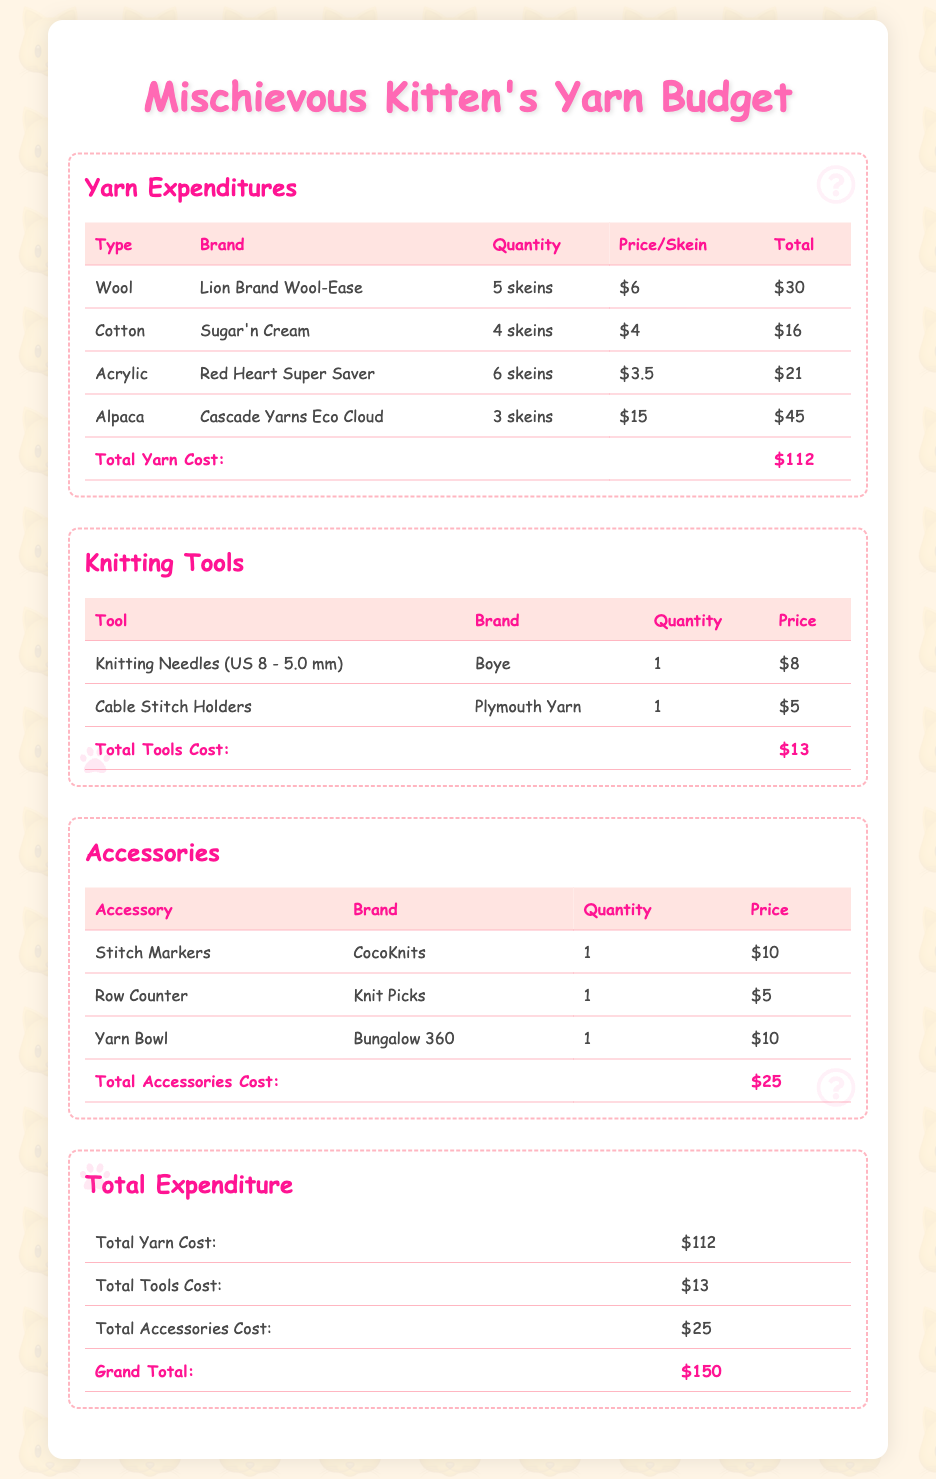what is the total yarn cost? The total yarn cost is the sum of all yarn expenditures listed, which is $30 + $16 + $21 + $45 = $112.
Answer: $112 how many skeins of cotton were purchased? The document states that 4 skeins of cotton were purchased.
Answer: 4 skeins who is the brand of the yarn bowl? The brand of the yarn bowl listed is Bungalow 360.
Answer: Bungalow 360 what is the cost of the knitting needles? The cost of the knitting needles is listed as $8 in the document.
Answer: $8 which type of yarn has the highest total cost? The type of yarn with the highest total cost is alpaca, which costs $45.
Answer: alpaca how many total knitting tools are listed in the budget? There are two knitting tools listed: knitting needles and cable stitch holders.
Answer: 2 what is the total accessories cost? The total accessories cost is the sum of all accessories listed, which is $10 + $5 + $10 = $25.
Answer: $25 what is the grand total of all expenditures? The grand total of all expenditures is calculated by adding up yarn ($112), tools ($13), and accessories ($25), making it $150.
Answer: $150 who is the brand of the row counter? The brand of the row counter listed is Knit Picks.
Answer: Knit Picks how many skeins of acrylic yarn were purchased? The document states that 6 skeins of acrylic yarn were purchased.
Answer: 6 skeins 